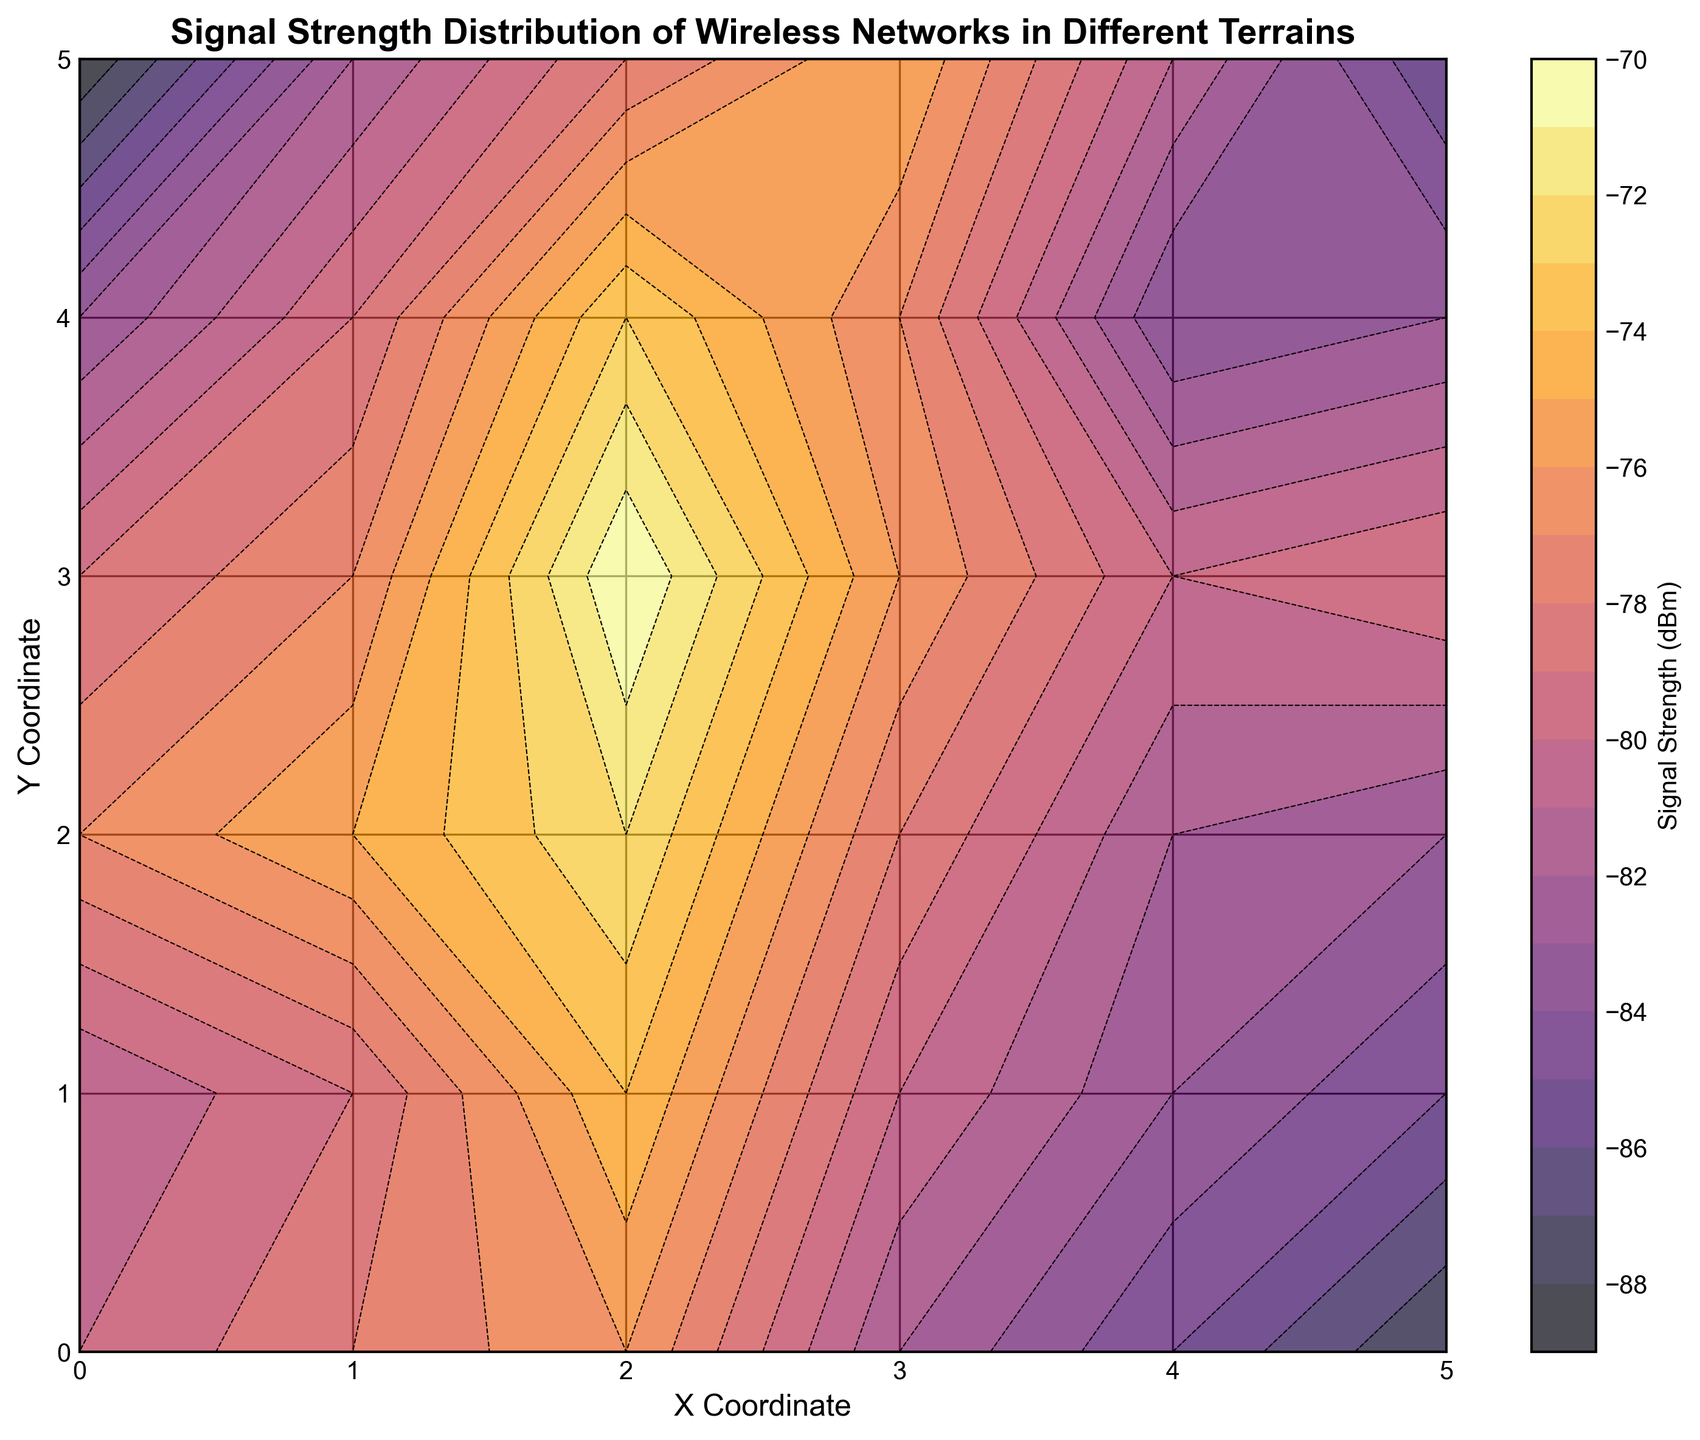What is the general trend of signal strength as you move from the Y=0 axis to the Y=5 axis? Upon examining the contour plot, the signal strength generally becomes weaker (more negative) as you move from the Y=0 axis to the Y=5 axis. This can be seen through the color gradient becoming darker.
Answer: Weaker Which region has the weakest signal strength? By looking at the color map, the darkest spot indicates the weakest signal strength. In this case, the coordinates around (0, 5) show the weakest signal strength.
Answer: Around (0, 5) Is there a particular region where the signal strength is consistently stronger than -75 dBm? In the color map, regions where the contour color is lighter indicate stronger signals. The area around (2, 2) has shades indicating signal strength consistently above -75 dBm.
Answer: Around (2, 2) How does signal strength compare between coordinates (0,0) and (5,5)? The contour plot shows different colors for these coordinates. At (0,0), the signal strength is -80 dBm, while at (5,5), it is -86 dBm. Hence, (0,0) has a stronger signal.
Answer: (0,0) has a stronger signal What is the average signal strength in the Y=1 row of the plot? The Y=1 row's signal strengths are -81, -79, -74, -80, -83, and -85 dBm. The sum is -482, and with 6 points, the average is -482/6.
Answer: -80.33 dBm Where do you see the largest gradient change in signal strength? The largest gradient change is visualized where the color changes most abruptly. Near the coordinates (0, 4) and (1, 5), there is a noticeable color transition indicating a steep gradient.
Answer: Near (0, 4) and (1, 5) Which x-coordinate has more regions with relatively strong signals (>-75 dBm)? Observing the color changes for different x-coordinates, x=2 has more light-colored regions, indicating stronger signals.
Answer: x=2 How does the visual appearance of the contour plot indicate signal strength distribution? The contour plot uses color gradients, where lighter colors represent stronger signal strengths and darker colors represent weaker signal strengths. Contour lines reinforce these gradients by visually segmenting different strength levels.
Answer: Lighter colors signify stronger signals What is the overall range of signal strength values present in the plot? Examining the color map and the signal strength values at different points, the range goes from the weakest -89 dBm to the strongest around -70 dBm.
Answer: -89 dBm to -70 dBm 